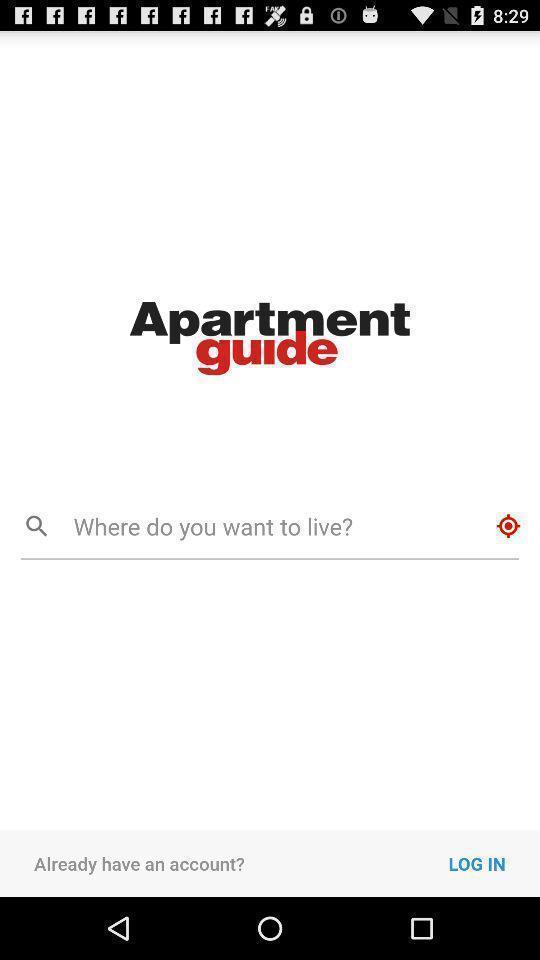Provide a detailed account of this screenshot. Welcome page of a renting app. 